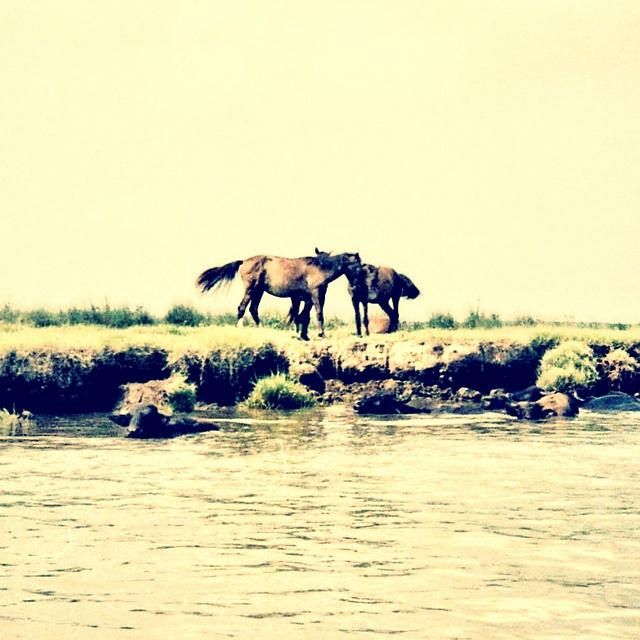How do the horses likely feel towards each other? Please explain your reasoning. friendly. The horses are friendly. 